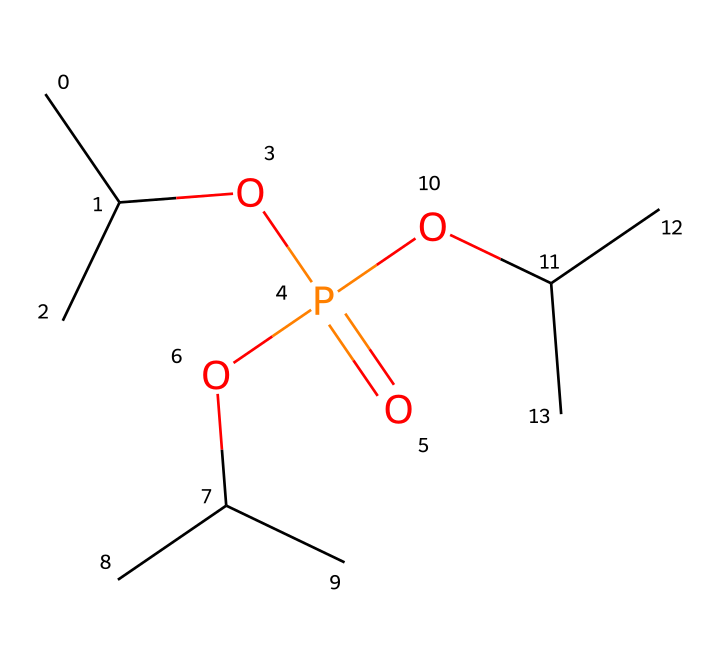What is the core atom of this compound? The chemical structure contains a phosphorus atom (P) that is central to its functionality, especially noted by the appearance of the phosphate group –OPO3 in its structure.
Answer: phosphorus How many carbon atoms are present in this chemical structure? By analyzing the SMILES representation, there are nine carbon atoms (C) evident in the structure since each 'C' indicates a carbon and we can count them directly as shown.
Answer: nine What functional groups are identified in the compound? The chemical contains a phosphate group (P(=O)(O)(O)) as it is an organophosphate, and it also contains alkyl groups indicated by the presence of multiple 'C' atoms along with 'O' for the ether functionality.
Answer: phosphate group, alkyl groups What is the degree of saturation of the compound? Examining the structure, there are no rings present, and since all carbons are connected with single bonds and the phosphorus atom connecting to oxygen, we identify it as a saturated compound.
Answer: saturated How many oxygen atoms are bonded to the phosphorus atom? In the structure, the phosphorus atom (P) forms a connection with three oxygen atoms, which can be noted from the multiple 'O' connections surrounding the phosphorus in the SMILES notation.
Answer: three What type of bonds are formed in the phosphate functional group? The phosphate functional group shown in the molecule features a combination of double and single bonds; specifically, it has a double bond with one oxygen atom and single bonds with the other two.
Answer: one double bond, two single bonds What makes this compound suitable for sensors in spacecraft? The presence of the phosphorus atom and the alkyl groups contribute to the stability and compatibility of this compound when exposed to various environmental and operational conditions, making it suitable for sensor applications in spacecraft.
Answer: stability and compatibility 